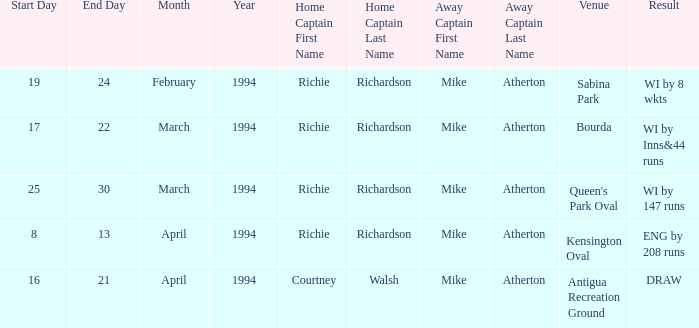Help me parse the entirety of this table. {'header': ['Start Day', 'End Day', 'Month', 'Year', 'Home Captain First Name', 'Home Captain Last Name', 'Away Captain First Name', 'Away Captain Last Name', 'Venue', 'Result'], 'rows': [['19', '24', 'February', '1994', 'Richie', 'Richardson', 'Mike', 'Atherton', 'Sabina Park', 'WI by 8 wkts'], ['17', '22', 'March', '1994', 'Richie', 'Richardson', 'Mike', 'Atherton', 'Bourda', 'WI by Inns&44 runs'], ['25', '30', 'March', '1994', 'Richie', 'Richardson', 'Mike', 'Atherton', "Queen's Park Oval", 'WI by 147 runs'], ['8', '13', 'April', '1994', 'Richie', 'Richardson', 'Mike', 'Atherton', 'Kensington Oval', 'ENG by 208 runs'], ['16', '21', 'April', '1994', 'Courtney', 'Walsh', 'Mike', 'Atherton', 'Antigua Recreation Ground', 'DRAW']]} Which Home Captain has Eng by 208 runs? Richie Richardson. 